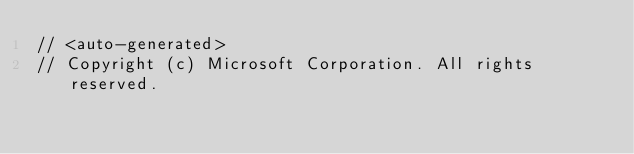<code> <loc_0><loc_0><loc_500><loc_500><_C#_>// <auto-generated>
// Copyright (c) Microsoft Corporation. All rights reserved.</code> 